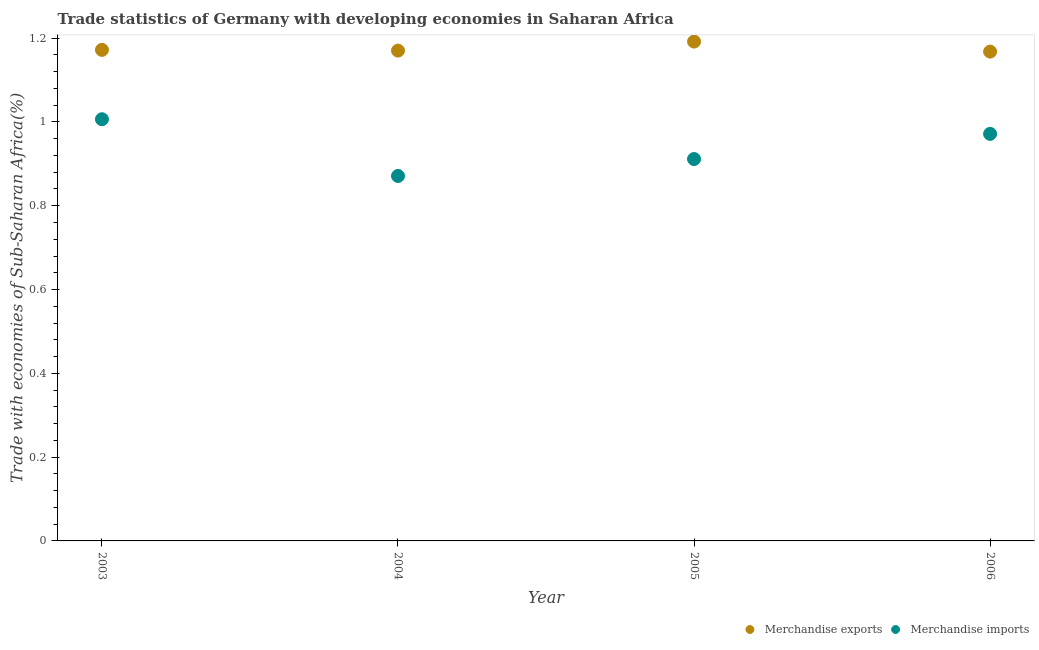What is the merchandise exports in 2004?
Make the answer very short. 1.17. Across all years, what is the maximum merchandise imports?
Provide a succinct answer. 1.01. Across all years, what is the minimum merchandise imports?
Ensure brevity in your answer.  0.87. In which year was the merchandise imports maximum?
Give a very brief answer. 2003. What is the total merchandise exports in the graph?
Your answer should be compact. 4.7. What is the difference between the merchandise exports in 2003 and that in 2005?
Ensure brevity in your answer.  -0.02. What is the difference between the merchandise exports in 2003 and the merchandise imports in 2006?
Give a very brief answer. 0.2. What is the average merchandise exports per year?
Provide a succinct answer. 1.18. In the year 2005, what is the difference between the merchandise exports and merchandise imports?
Give a very brief answer. 0.28. In how many years, is the merchandise exports greater than 1.12 %?
Provide a short and direct response. 4. What is the ratio of the merchandise exports in 2004 to that in 2005?
Provide a succinct answer. 0.98. What is the difference between the highest and the second highest merchandise exports?
Keep it short and to the point. 0.02. What is the difference between the highest and the lowest merchandise imports?
Keep it short and to the point. 0.14. In how many years, is the merchandise exports greater than the average merchandise exports taken over all years?
Keep it short and to the point. 1. Does the merchandise exports monotonically increase over the years?
Offer a terse response. No. Is the merchandise imports strictly less than the merchandise exports over the years?
Offer a terse response. Yes. How many years are there in the graph?
Give a very brief answer. 4. Are the values on the major ticks of Y-axis written in scientific E-notation?
Provide a short and direct response. No. Does the graph contain any zero values?
Your answer should be very brief. No. Where does the legend appear in the graph?
Offer a terse response. Bottom right. How many legend labels are there?
Make the answer very short. 2. How are the legend labels stacked?
Keep it short and to the point. Horizontal. What is the title of the graph?
Offer a terse response. Trade statistics of Germany with developing economies in Saharan Africa. What is the label or title of the X-axis?
Your response must be concise. Year. What is the label or title of the Y-axis?
Your answer should be very brief. Trade with economies of Sub-Saharan Africa(%). What is the Trade with economies of Sub-Saharan Africa(%) in Merchandise exports in 2003?
Make the answer very short. 1.17. What is the Trade with economies of Sub-Saharan Africa(%) of Merchandise imports in 2003?
Your answer should be compact. 1.01. What is the Trade with economies of Sub-Saharan Africa(%) of Merchandise exports in 2004?
Offer a very short reply. 1.17. What is the Trade with economies of Sub-Saharan Africa(%) in Merchandise imports in 2004?
Offer a very short reply. 0.87. What is the Trade with economies of Sub-Saharan Africa(%) of Merchandise exports in 2005?
Provide a succinct answer. 1.19. What is the Trade with economies of Sub-Saharan Africa(%) of Merchandise imports in 2005?
Make the answer very short. 0.91. What is the Trade with economies of Sub-Saharan Africa(%) of Merchandise exports in 2006?
Your answer should be very brief. 1.17. What is the Trade with economies of Sub-Saharan Africa(%) of Merchandise imports in 2006?
Ensure brevity in your answer.  0.97. Across all years, what is the maximum Trade with economies of Sub-Saharan Africa(%) of Merchandise exports?
Your answer should be compact. 1.19. Across all years, what is the maximum Trade with economies of Sub-Saharan Africa(%) in Merchandise imports?
Provide a short and direct response. 1.01. Across all years, what is the minimum Trade with economies of Sub-Saharan Africa(%) of Merchandise exports?
Offer a terse response. 1.17. Across all years, what is the minimum Trade with economies of Sub-Saharan Africa(%) of Merchandise imports?
Provide a succinct answer. 0.87. What is the total Trade with economies of Sub-Saharan Africa(%) of Merchandise exports in the graph?
Your response must be concise. 4.7. What is the total Trade with economies of Sub-Saharan Africa(%) of Merchandise imports in the graph?
Ensure brevity in your answer.  3.76. What is the difference between the Trade with economies of Sub-Saharan Africa(%) in Merchandise exports in 2003 and that in 2004?
Offer a very short reply. 0. What is the difference between the Trade with economies of Sub-Saharan Africa(%) in Merchandise imports in 2003 and that in 2004?
Your response must be concise. 0.14. What is the difference between the Trade with economies of Sub-Saharan Africa(%) of Merchandise exports in 2003 and that in 2005?
Offer a terse response. -0.02. What is the difference between the Trade with economies of Sub-Saharan Africa(%) of Merchandise imports in 2003 and that in 2005?
Your answer should be compact. 0.1. What is the difference between the Trade with economies of Sub-Saharan Africa(%) in Merchandise exports in 2003 and that in 2006?
Make the answer very short. 0. What is the difference between the Trade with economies of Sub-Saharan Africa(%) of Merchandise imports in 2003 and that in 2006?
Give a very brief answer. 0.04. What is the difference between the Trade with economies of Sub-Saharan Africa(%) in Merchandise exports in 2004 and that in 2005?
Your response must be concise. -0.02. What is the difference between the Trade with economies of Sub-Saharan Africa(%) of Merchandise imports in 2004 and that in 2005?
Provide a succinct answer. -0.04. What is the difference between the Trade with economies of Sub-Saharan Africa(%) in Merchandise exports in 2004 and that in 2006?
Make the answer very short. 0. What is the difference between the Trade with economies of Sub-Saharan Africa(%) in Merchandise imports in 2004 and that in 2006?
Provide a short and direct response. -0.1. What is the difference between the Trade with economies of Sub-Saharan Africa(%) in Merchandise exports in 2005 and that in 2006?
Provide a short and direct response. 0.02. What is the difference between the Trade with economies of Sub-Saharan Africa(%) in Merchandise imports in 2005 and that in 2006?
Keep it short and to the point. -0.06. What is the difference between the Trade with economies of Sub-Saharan Africa(%) of Merchandise exports in 2003 and the Trade with economies of Sub-Saharan Africa(%) of Merchandise imports in 2004?
Offer a very short reply. 0.3. What is the difference between the Trade with economies of Sub-Saharan Africa(%) in Merchandise exports in 2003 and the Trade with economies of Sub-Saharan Africa(%) in Merchandise imports in 2005?
Make the answer very short. 0.26. What is the difference between the Trade with economies of Sub-Saharan Africa(%) in Merchandise exports in 2003 and the Trade with economies of Sub-Saharan Africa(%) in Merchandise imports in 2006?
Offer a very short reply. 0.2. What is the difference between the Trade with economies of Sub-Saharan Africa(%) of Merchandise exports in 2004 and the Trade with economies of Sub-Saharan Africa(%) of Merchandise imports in 2005?
Give a very brief answer. 0.26. What is the difference between the Trade with economies of Sub-Saharan Africa(%) in Merchandise exports in 2004 and the Trade with economies of Sub-Saharan Africa(%) in Merchandise imports in 2006?
Ensure brevity in your answer.  0.2. What is the difference between the Trade with economies of Sub-Saharan Africa(%) of Merchandise exports in 2005 and the Trade with economies of Sub-Saharan Africa(%) of Merchandise imports in 2006?
Keep it short and to the point. 0.22. What is the average Trade with economies of Sub-Saharan Africa(%) of Merchandise exports per year?
Keep it short and to the point. 1.18. What is the average Trade with economies of Sub-Saharan Africa(%) of Merchandise imports per year?
Make the answer very short. 0.94. In the year 2003, what is the difference between the Trade with economies of Sub-Saharan Africa(%) of Merchandise exports and Trade with economies of Sub-Saharan Africa(%) of Merchandise imports?
Offer a terse response. 0.17. In the year 2004, what is the difference between the Trade with economies of Sub-Saharan Africa(%) of Merchandise exports and Trade with economies of Sub-Saharan Africa(%) of Merchandise imports?
Keep it short and to the point. 0.3. In the year 2005, what is the difference between the Trade with economies of Sub-Saharan Africa(%) in Merchandise exports and Trade with economies of Sub-Saharan Africa(%) in Merchandise imports?
Provide a succinct answer. 0.28. In the year 2006, what is the difference between the Trade with economies of Sub-Saharan Africa(%) of Merchandise exports and Trade with economies of Sub-Saharan Africa(%) of Merchandise imports?
Your answer should be compact. 0.2. What is the ratio of the Trade with economies of Sub-Saharan Africa(%) in Merchandise exports in 2003 to that in 2004?
Your response must be concise. 1. What is the ratio of the Trade with economies of Sub-Saharan Africa(%) in Merchandise imports in 2003 to that in 2004?
Make the answer very short. 1.16. What is the ratio of the Trade with economies of Sub-Saharan Africa(%) in Merchandise exports in 2003 to that in 2005?
Your response must be concise. 0.98. What is the ratio of the Trade with economies of Sub-Saharan Africa(%) of Merchandise imports in 2003 to that in 2005?
Provide a short and direct response. 1.1. What is the ratio of the Trade with economies of Sub-Saharan Africa(%) in Merchandise imports in 2003 to that in 2006?
Keep it short and to the point. 1.04. What is the ratio of the Trade with economies of Sub-Saharan Africa(%) of Merchandise exports in 2004 to that in 2005?
Offer a terse response. 0.98. What is the ratio of the Trade with economies of Sub-Saharan Africa(%) of Merchandise imports in 2004 to that in 2005?
Ensure brevity in your answer.  0.96. What is the ratio of the Trade with economies of Sub-Saharan Africa(%) in Merchandise imports in 2004 to that in 2006?
Provide a succinct answer. 0.9. What is the ratio of the Trade with economies of Sub-Saharan Africa(%) in Merchandise exports in 2005 to that in 2006?
Your answer should be very brief. 1.02. What is the ratio of the Trade with economies of Sub-Saharan Africa(%) in Merchandise imports in 2005 to that in 2006?
Make the answer very short. 0.94. What is the difference between the highest and the second highest Trade with economies of Sub-Saharan Africa(%) in Merchandise exports?
Your answer should be very brief. 0.02. What is the difference between the highest and the second highest Trade with economies of Sub-Saharan Africa(%) of Merchandise imports?
Provide a short and direct response. 0.04. What is the difference between the highest and the lowest Trade with economies of Sub-Saharan Africa(%) of Merchandise exports?
Provide a succinct answer. 0.02. What is the difference between the highest and the lowest Trade with economies of Sub-Saharan Africa(%) in Merchandise imports?
Your answer should be compact. 0.14. 